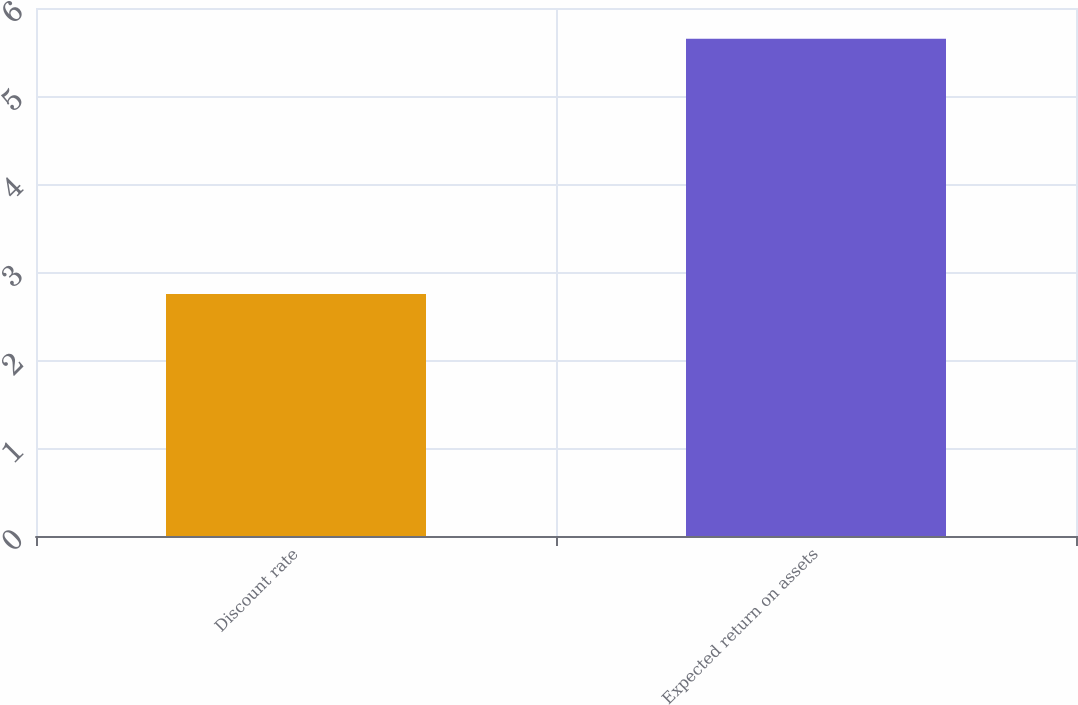Convert chart. <chart><loc_0><loc_0><loc_500><loc_500><bar_chart><fcel>Discount rate<fcel>Expected return on assets<nl><fcel>2.75<fcel>5.65<nl></chart> 